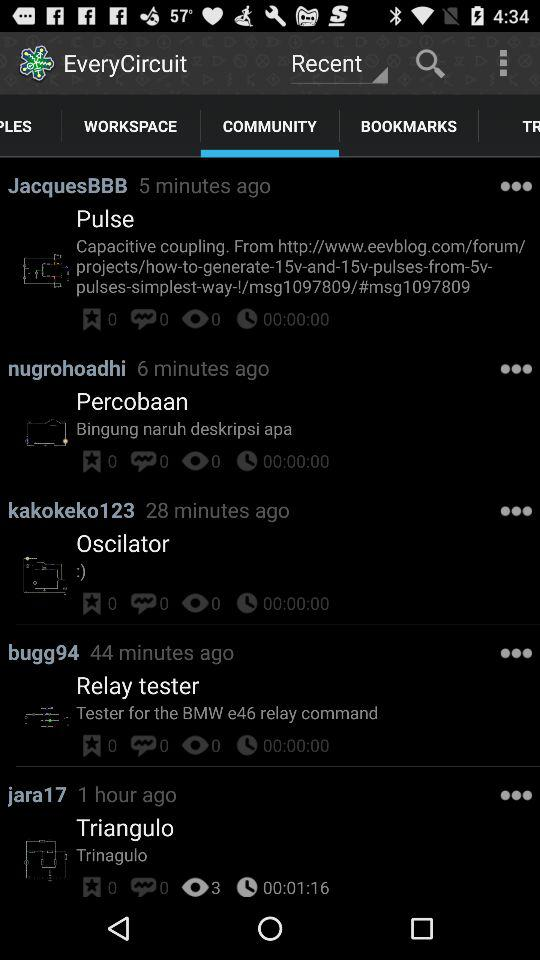How many comments are there on the post of "bugg94" in "COMMUNITY"? There are 0 comments. 